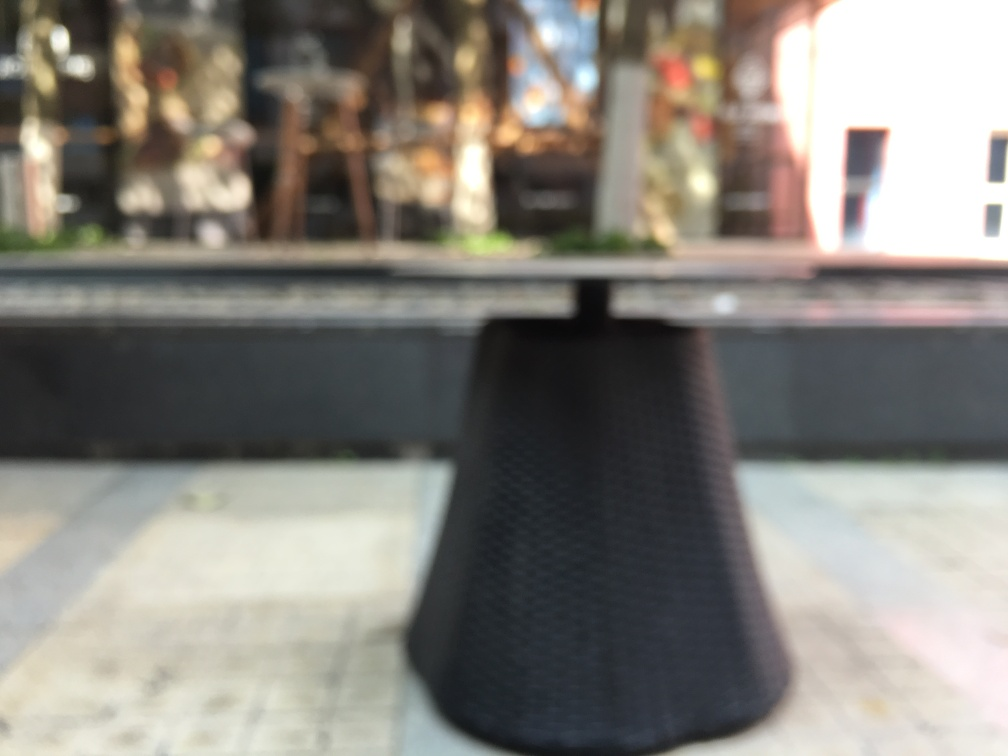Can you describe the setting behind the table? Despite the blurry nature of the image, one can discern a suggestion of an outdoor or semi-outdoor setting with objects that appear to be plants and possibly other furniture. There could be a storefront or patio area in the background, indicated by the shapes and varying tones that resemble typical outdoor commercial spaces. 